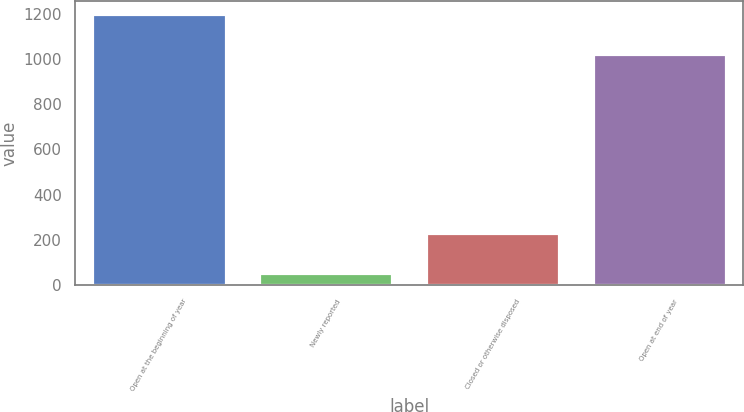<chart> <loc_0><loc_0><loc_500><loc_500><bar_chart><fcel>Open at the beginning of year<fcel>Newly reported<fcel>Closed or otherwise disposed<fcel>Open at end of year<nl><fcel>1198<fcel>54<fcel>229<fcel>1023<nl></chart> 